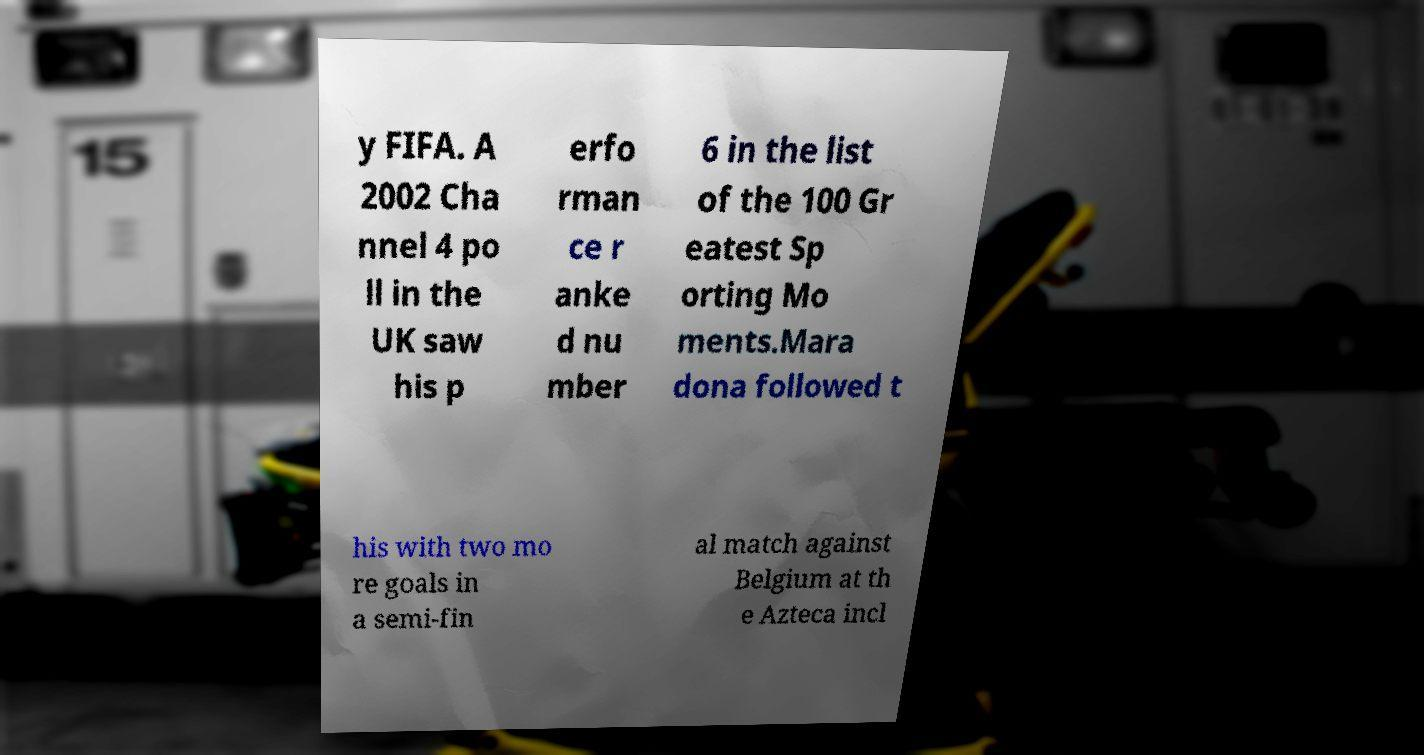Could you assist in decoding the text presented in this image and type it out clearly? y FIFA. A 2002 Cha nnel 4 po ll in the UK saw his p erfo rman ce r anke d nu mber 6 in the list of the 100 Gr eatest Sp orting Mo ments.Mara dona followed t his with two mo re goals in a semi-fin al match against Belgium at th e Azteca incl 